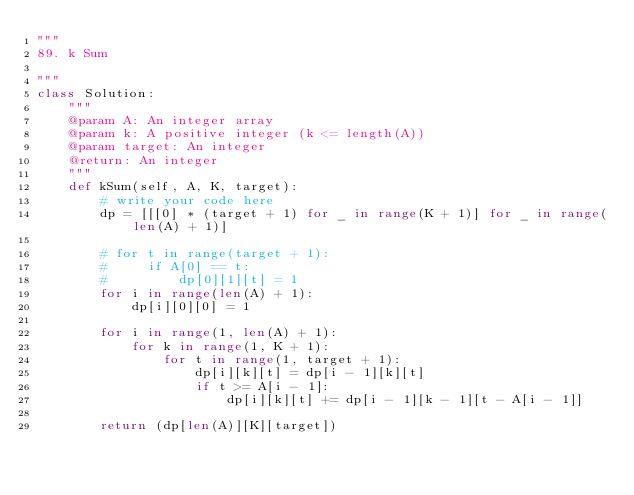<code> <loc_0><loc_0><loc_500><loc_500><_Python_>"""
89. k Sum

"""
class Solution:
    """
    @param A: An integer array
    @param k: A positive integer (k <= length(A))
    @param target: An integer
    @return: An integer
    """
    def kSum(self, A, K, target):
        # write your code here
        dp = [[[0] * (target + 1) for _ in range(K + 1)] for _ in range(len(A) + 1)]

        # for t in range(target + 1):
        #     if A[0] == t:
        #         dp[0][1][t] = 1
        for i in range(len(A) + 1):
            dp[i][0][0] = 1

        for i in range(1, len(A) + 1):
            for k in range(1, K + 1):
                for t in range(1, target + 1):
                    dp[i][k][t] = dp[i - 1][k][t]
                    if t >= A[i - 1]:
                        dp[i][k][t] += dp[i - 1][k - 1][t - A[i - 1]]

        return (dp[len(A)][K][target])
</code> 